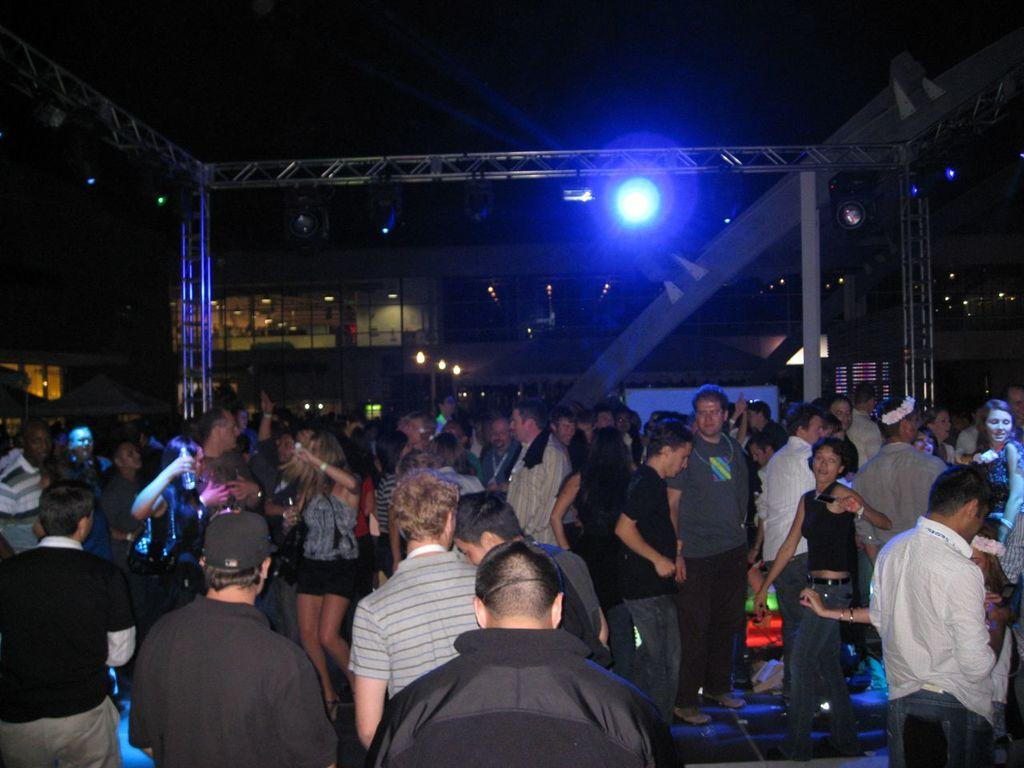How many people are present in the image? There are many people in the image. What can be seen in the middle of the image? There is a light in the middle of the image. What are the people in the image doing? People are dancing in the middle of the image. Where is the basket located in the image? There is no basket present in the image. What type of medical equipment can be seen in the image? There is no hospital or medical equipment present in the image. What is the purpose of the cork in the image? There is no cork present in the image. 